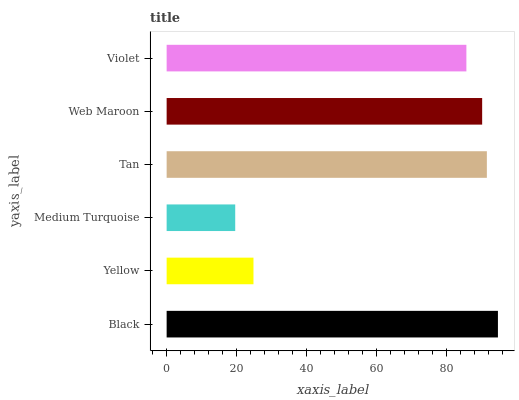Is Medium Turquoise the minimum?
Answer yes or no. Yes. Is Black the maximum?
Answer yes or no. Yes. Is Yellow the minimum?
Answer yes or no. No. Is Yellow the maximum?
Answer yes or no. No. Is Black greater than Yellow?
Answer yes or no. Yes. Is Yellow less than Black?
Answer yes or no. Yes. Is Yellow greater than Black?
Answer yes or no. No. Is Black less than Yellow?
Answer yes or no. No. Is Web Maroon the high median?
Answer yes or no. Yes. Is Violet the low median?
Answer yes or no. Yes. Is Tan the high median?
Answer yes or no. No. Is Tan the low median?
Answer yes or no. No. 